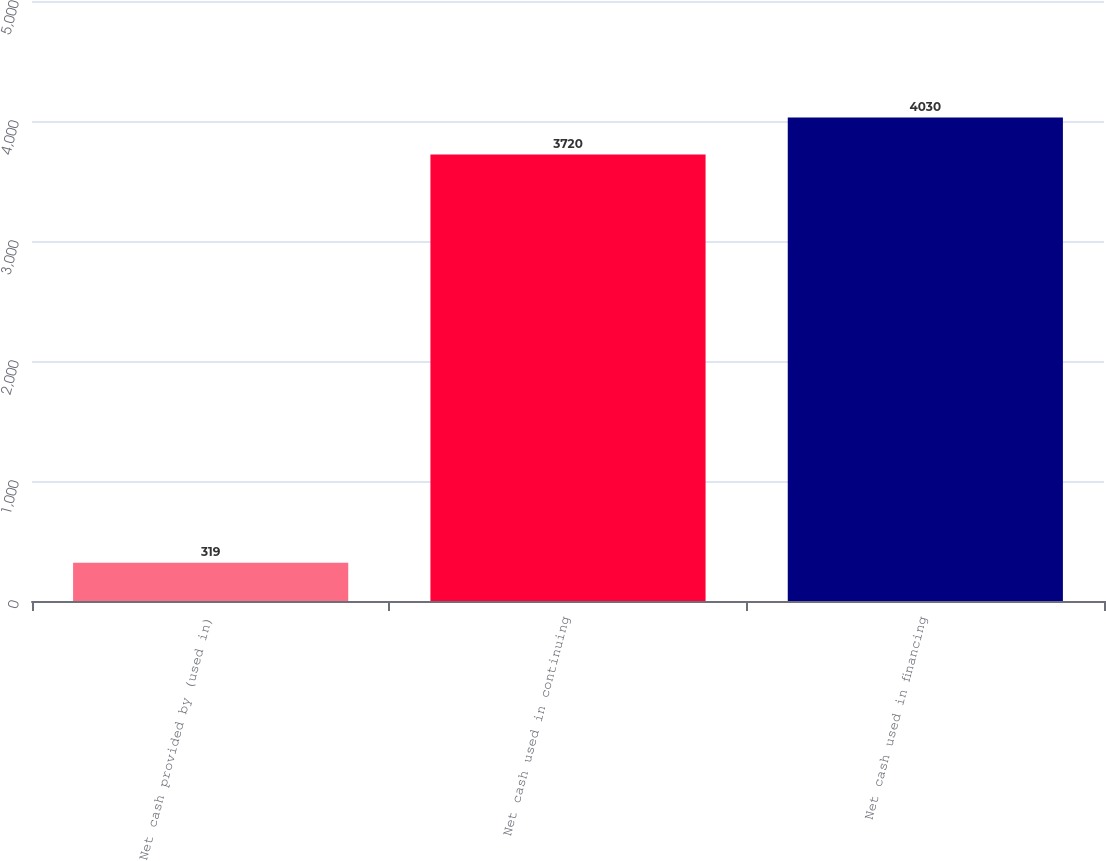<chart> <loc_0><loc_0><loc_500><loc_500><bar_chart><fcel>Net cash provided by (used in)<fcel>Net cash used in continuing<fcel>Net cash used in financing<nl><fcel>319<fcel>3720<fcel>4030<nl></chart> 